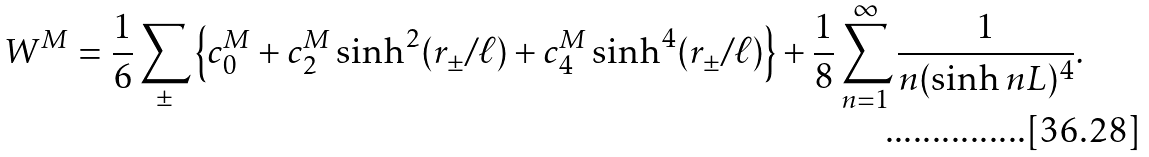<formula> <loc_0><loc_0><loc_500><loc_500>W ^ { M } = \frac { 1 } { 6 } \sum _ { \pm } \left \{ c _ { 0 } ^ { M } + c _ { 2 } ^ { M } \sinh ^ { 2 } ( r _ { \pm } / \ell ) + c _ { 4 } ^ { M } \sinh ^ { 4 } ( r _ { \pm } / \ell ) \right \} + \frac { 1 } { 8 } \sum _ { n = 1 } ^ { \infty } \frac { 1 } { n ( \sinh n L ) ^ { 4 } } .</formula> 